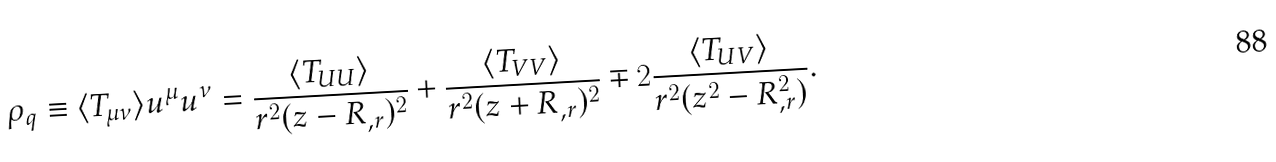<formula> <loc_0><loc_0><loc_500><loc_500>\rho _ { q } \equiv \langle T _ { \mu \nu } \rangle u ^ { \mu } u ^ { \nu } = \frac { \langle T _ { U U } \rangle } { r ^ { 2 } ( z - R _ { , r } ) ^ { 2 } } + \frac { \langle T _ { V V } \rangle } { r ^ { 2 } ( z + R _ { , r } ) ^ { 2 } } \mp 2 \frac { \langle T _ { U V } \rangle } { r ^ { 2 } ( z ^ { 2 } - R _ { , r } ^ { 2 } ) } .</formula> 